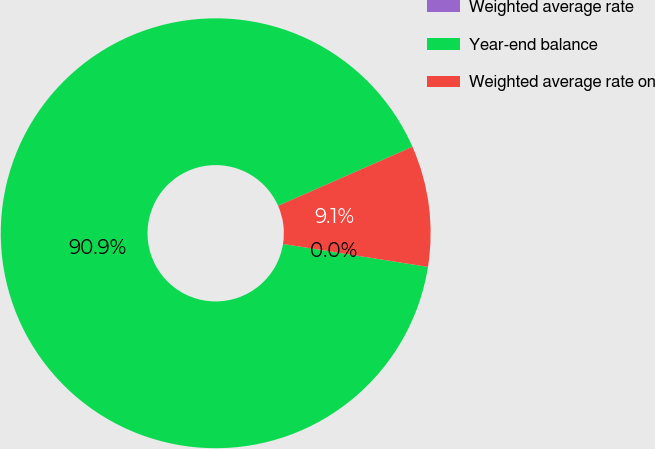Convert chart to OTSL. <chart><loc_0><loc_0><loc_500><loc_500><pie_chart><fcel>Weighted average rate<fcel>Year-end balance<fcel>Weighted average rate on<nl><fcel>0.0%<fcel>90.91%<fcel>9.09%<nl></chart> 